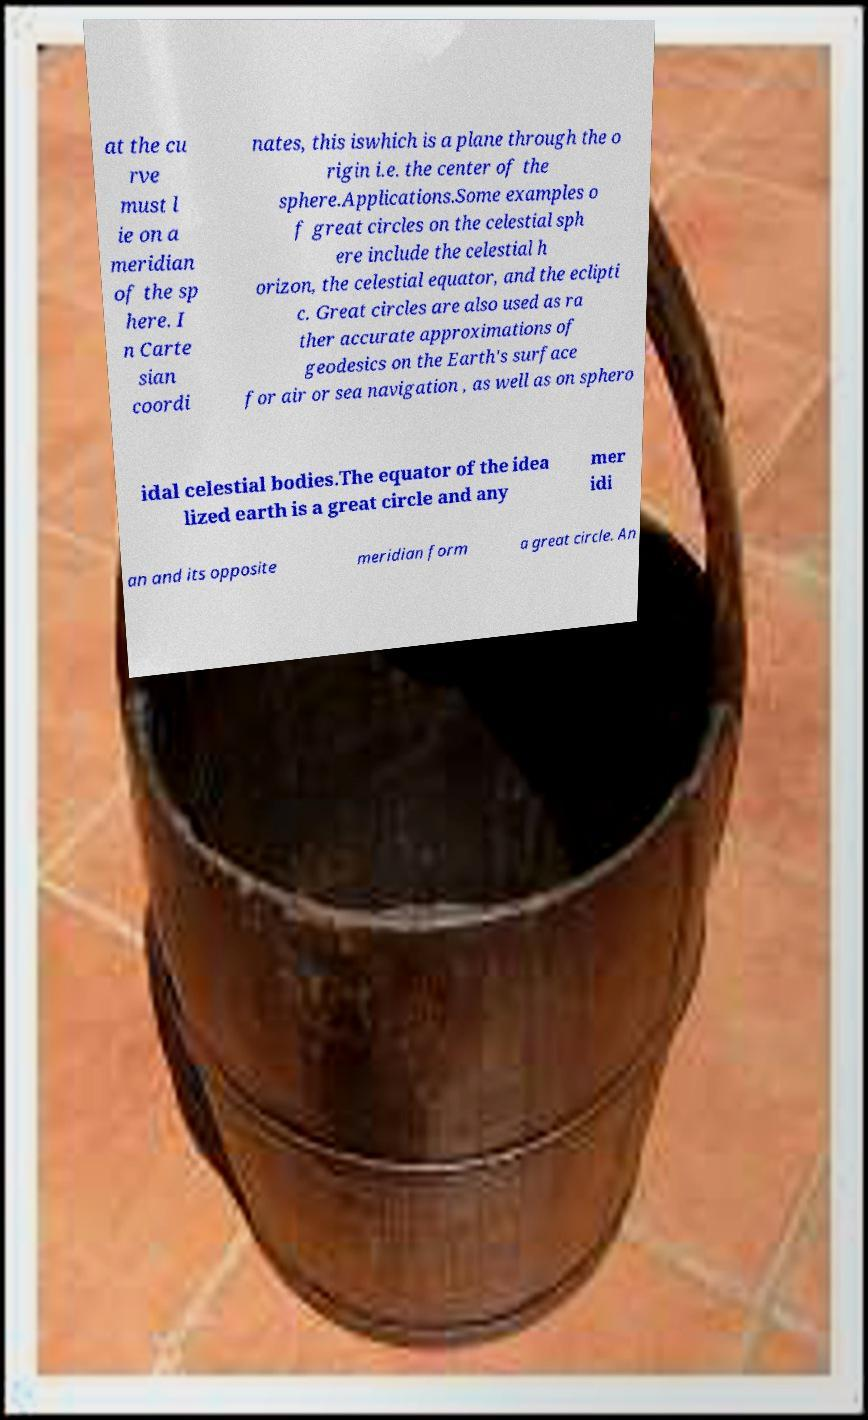For documentation purposes, I need the text within this image transcribed. Could you provide that? at the cu rve must l ie on a meridian of the sp here. I n Carte sian coordi nates, this iswhich is a plane through the o rigin i.e. the center of the sphere.Applications.Some examples o f great circles on the celestial sph ere include the celestial h orizon, the celestial equator, and the eclipti c. Great circles are also used as ra ther accurate approximations of geodesics on the Earth's surface for air or sea navigation , as well as on sphero idal celestial bodies.The equator of the idea lized earth is a great circle and any mer idi an and its opposite meridian form a great circle. An 